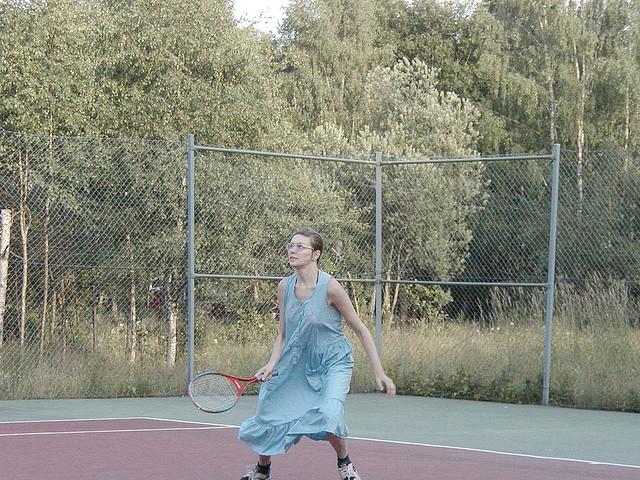Is she wearing a tennis outfit?
Be succinct. No. Is she wearing proper clothing for tennis?
Short answer required. No. Why is the fence so high around the court?
Quick response, please. Keep balls in. What sport is the lady playing?
Short answer required. Tennis. What color is the court?
Give a very brief answer. Red. What color is the fence?
Answer briefly. Silver. Is this blurry?
Answer briefly. No. 